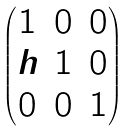Convert formula to latex. <formula><loc_0><loc_0><loc_500><loc_500>\begin{pmatrix} 1 & 0 & 0 \\ h & 1 & 0 \\ 0 & 0 & 1 \\ \end{pmatrix}</formula> 